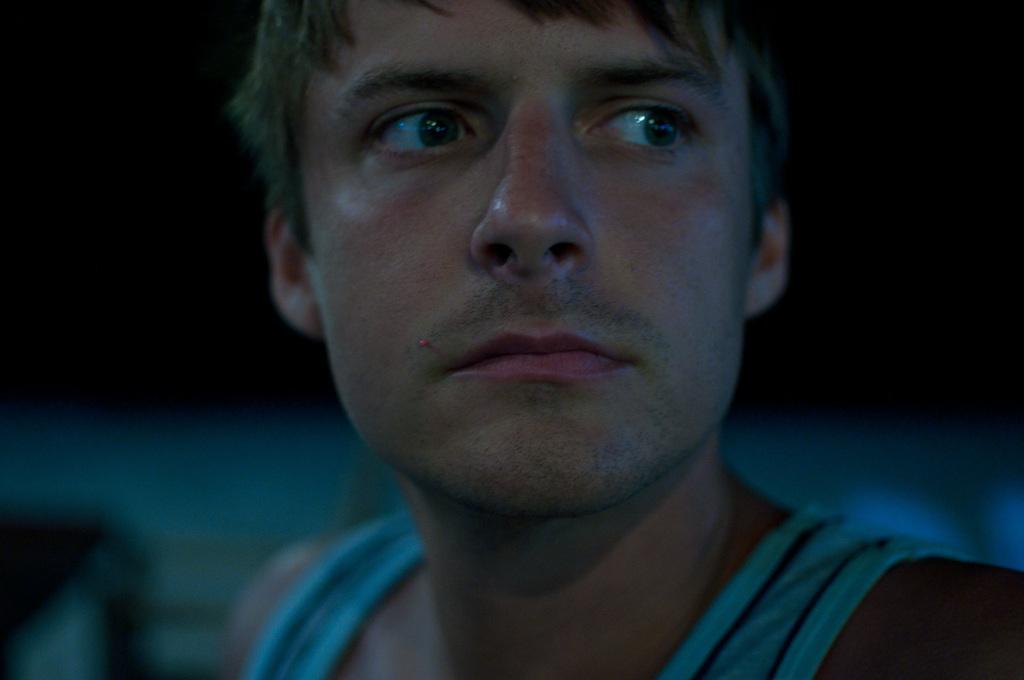Can you describe this image briefly? In this image we can see a man. In the background the image is dark and blur. 